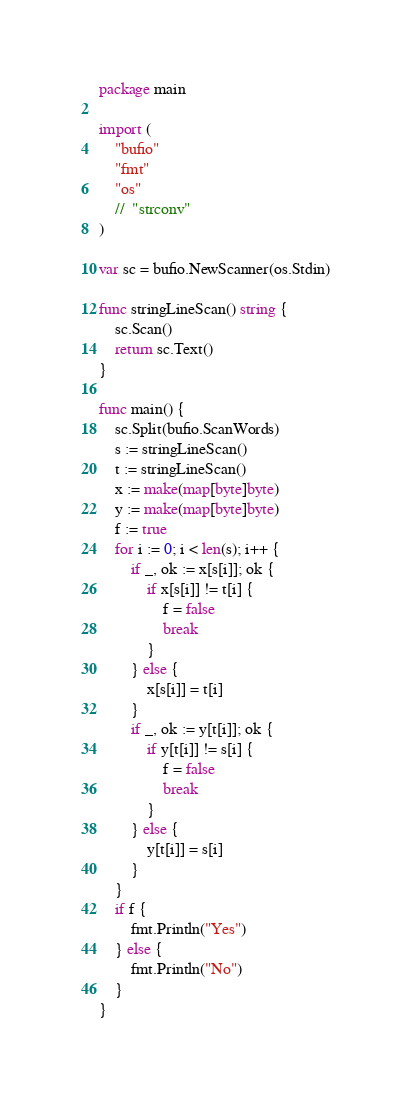<code> <loc_0><loc_0><loc_500><loc_500><_Go_>package main

import (
	"bufio"
	"fmt"
	"os"
	//	"strconv"
)

var sc = bufio.NewScanner(os.Stdin)

func stringLineScan() string {
	sc.Scan()
	return sc.Text()
}

func main() {
	sc.Split(bufio.ScanWords)
	s := stringLineScan()
	t := stringLineScan()
	x := make(map[byte]byte)
	y := make(map[byte]byte)
	f := true
	for i := 0; i < len(s); i++ {
		if _, ok := x[s[i]]; ok {
			if x[s[i]] != t[i] {
				f = false
				break
			}
		} else {
			x[s[i]] = t[i]
		}
		if _, ok := y[t[i]]; ok {
			if y[t[i]] != s[i] {
				f = false
				break
			}
		} else {
			y[t[i]] = s[i]
		}
	}
	if f {
		fmt.Println("Yes")
	} else {
		fmt.Println("No")
	}
}</code> 